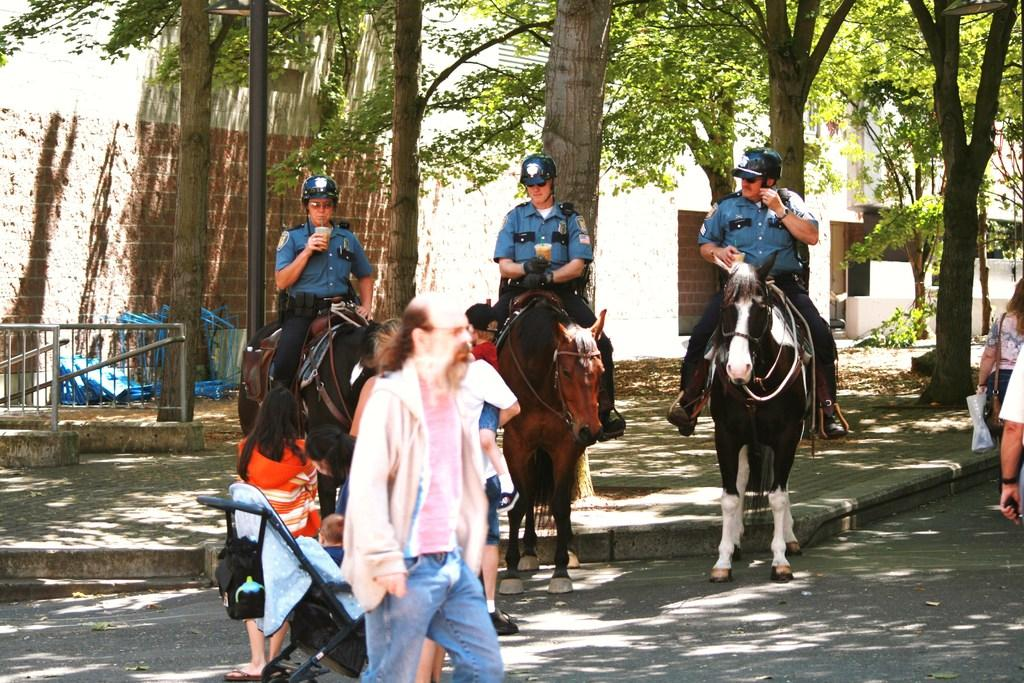How many men are in the image? There are three men in the image. What are the men doing in the image? The men are sitting on a horse. What can be seen on the ground in the image? There are people on a path in the image. What is visible in the background of the image? There are trees and a wall in the background of the image. How much money is being exchanged between the men on the horse in the image? There is no indication of money being exchanged in the image; the men are simply sitting on a horse. What type of brush is being used by the man on the horse to groom the horse in the image? There is no brush present in the image, nor is there any grooming activity taking place. 